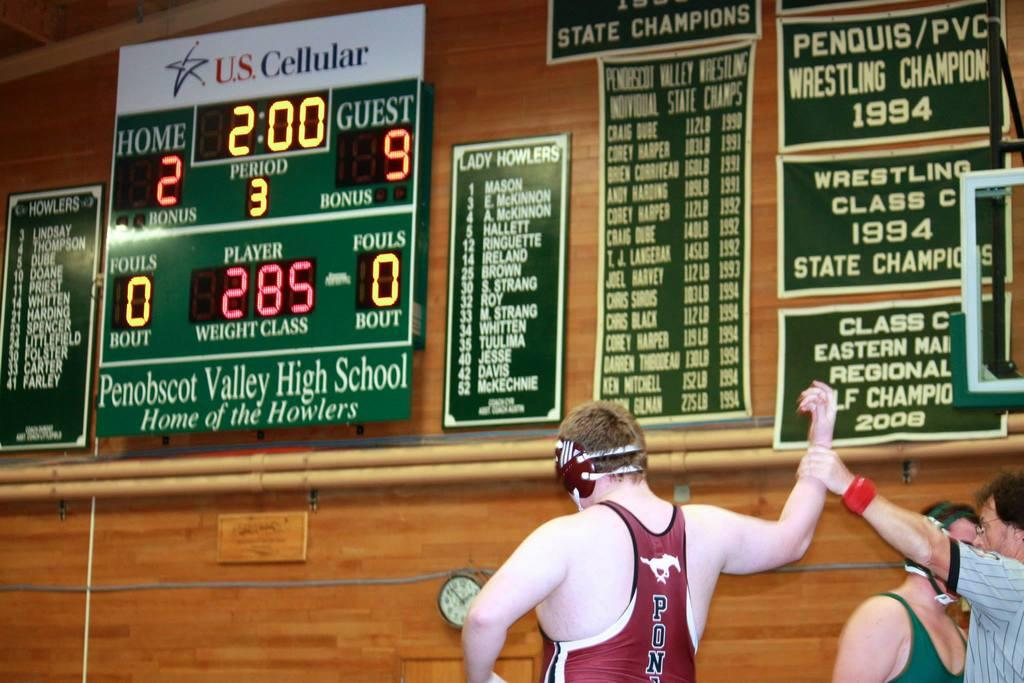Provide a one-sentence caption for the provided image. Three wrestlers where the referree is holding up the right arm of the wrestler dressed in red pony tank top. 